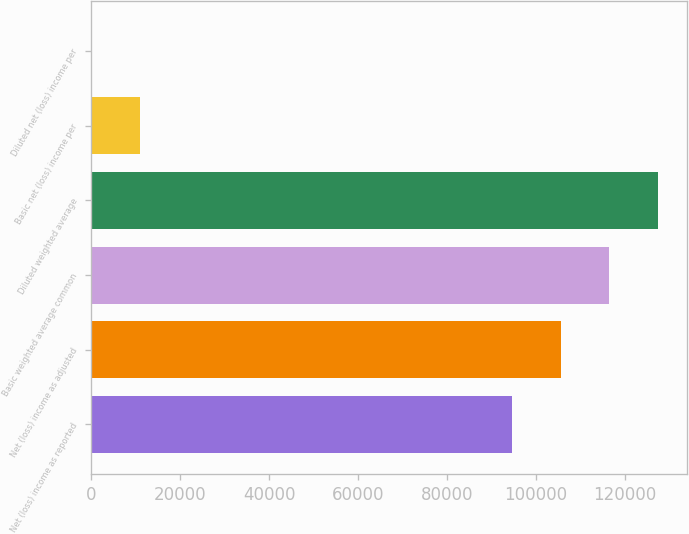<chart> <loc_0><loc_0><loc_500><loc_500><bar_chart><fcel>Net (loss) income as reported<fcel>Net (loss) income as adjusted<fcel>Basic weighted average common<fcel>Diluted weighted average<fcel>Basic net (loss) income per<fcel>Diluted net (loss) income per<nl><fcel>94578<fcel>105545<fcel>116512<fcel>127478<fcel>10967.7<fcel>0.86<nl></chart> 